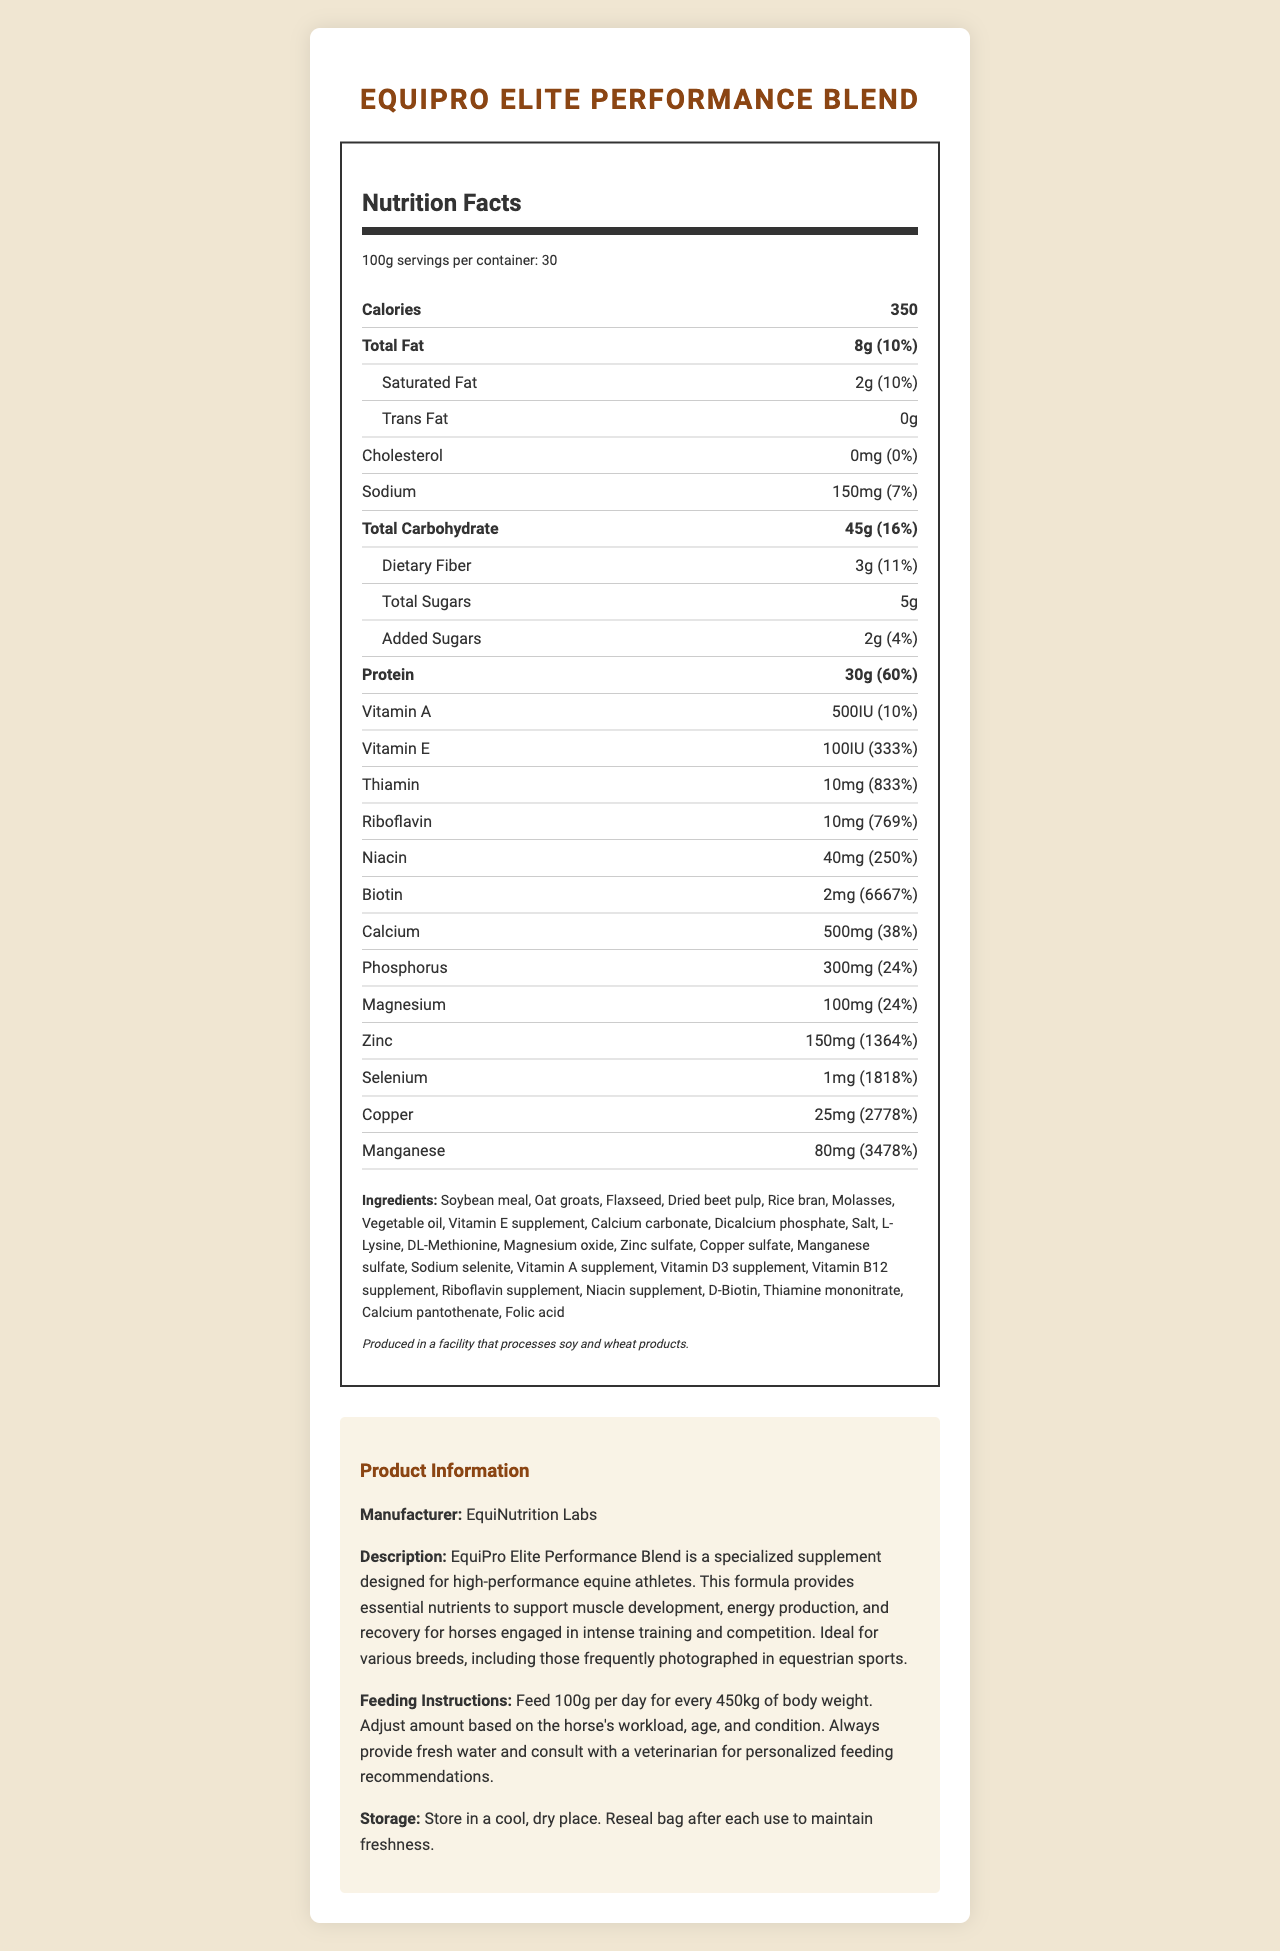what is the serving size for EquiPro Elite Performance Blend? The document states that the serving size is "100g."
Answer: 100g how many servings are there per container? The document indicates there are "30 servings per container."
Answer: 30 servings how many calories are in one serving of EquiPro Elite Performance Blend? The document shows that each serving contains "350 calories."
Answer: 350 calories how much protein does one serving provide? According to the document, one serving provides "30g of protein."
Answer: 30g what is the daily value percentage for protein per serving? The document lists that the daily value for protein is "60%."
Answer: 60% which nutrient has the highest daily value percentage per serving? A. Biotin B. Selenium C. Manganese D. Riboflavin The document indicates that Manganese has the highest daily value percentage at "3478%."
Answer: C which ingredients are in EquiPro Elite Performance Blend? A. Soybean meal B. Oat groats C. Rice bran D. All of the above The ingredients list in the document includes "Soybean meal," "Oat groats," and "Rice bran" among others, making "All of the above" the correct option.
Answer: D is the product free of cholesterol? The document lists "Cholesterol: 0mg (0%)" indicating it is free of cholesterol.
Answer: Yes summarize the main purpose of the EquiPro Elite Performance Blend This summary describes the overarching goal of the product, which is detailed in the product description and the nutrients listed in the document.
Answer: The EquiPro Elite Performance Blend is a specialized supplement designed to support high-performance equine athletes by providing essential nutrients for muscle development, energy production, and recovery during intense training and competition. what is the specific daily value percentage for Riboflavin? The document provides the daily value percentage for Riboflavin as "769%."
Answer: 769% is EquiPro Elite Performance Blend suitable for horses allergic to soy? The allergen information states that it is "Produced in a facility that processes soy and wheat products," making it unsuitable for horses allergic to soy.
Answer: No describe the feeding instructions given for EquiPro Elite Performance Blend The feeding instructions detail how much of the supplement to feed based on the horse's weight, and they suggest adjustments based on other conditions. They also recommend providing fresh water and consulting a veterinarian for personalized advice.
Answer: Feed 100g per day for every 450kg of body weight. Adjust amount based on the horse's workload, age, and condition. Always provide fresh water and consult with a veterinarian for personalized feeding recommendations. what is the manufacturer of EquiPro Elite Performance Blend? The document specifies that the product is manufactured by "EquiNutrition Labs."
Answer: EquiNutrition Labs what is the total amount of dietary fiber per serving? The document lists "Dietary Fiber: 3g" per serving.
Answer: 3g what is the daily value percentage for calcium per serving? The document indicates that the daily value percentage for calcium is "38%."
Answer: 38% list the vitamins included in EquiPro Elite Performance Blend The document lists these vitamins in the nutrition facts section under their respective nutrient values.
Answer: Vitamin A, Vitamin E, Thiamin, Riboflavin, Niacin, Biotin, Vitamin D3, Vitamin B12 what is the exact amount of zinc in one serving? The document states there is "150mg" of zinc per serving.
Answer: 150mg how much saturated fat does the supplement contain per serving? The document lists "Saturated Fat: 2g" per serving.
Answer: 2g how many grams of total sugars are there per serving? According to the document, there are "Total Sugars: 5g" per serving.
Answer: 5g what is the breakdown of the daily value percentages for Sodium, Total Carbohydrate, and Dietary Fiber? The document lists these daily value percentages for Sodium, Total Carbohydrate, and Dietary Fiber respectively.
Answer: Sodium: 7%, Total Carbohydrate: 16%, Dietary Fiber: 11% why is EquiPro Elite Performance Blend ideal for various breeds? According to the product description, the blend is designed to aid high-performance equine athletes regardless of breed, by supplying necessary nutrients for their demanding activities.
Answer: It provides essential nutrients to support muscle development, energy production, and recovery for horses engaged in intense training and competition. how much biotin is there per serving, and what is its daily value percentage? The document lists "Biotin: 2mg" with a daily value percentage of "6667%."
Answer: 2mg, 6667% is there any information about how the product is processed in relation to allergens? The document states it is "Produced in a facility that processes soy and wheat products."
Answer: Yes what is the storage instruction for EquiPro Elite Performance Blend? The storage instructions indicate to store in a cool, dry place and to reseal the bag after each use to keep the product fresh.
Answer: Store in a cool, dry place. Reseal bag after each use to maintain freshness. how many total grams of fat are in one serving? The document mentions "Total Fat: 8g" per serving.
Answer: 8g can you determine the cost of the product from the document? The document does not contain any pricing information for the EquiPro Elite Performance Blend.
Answer: Not enough information 